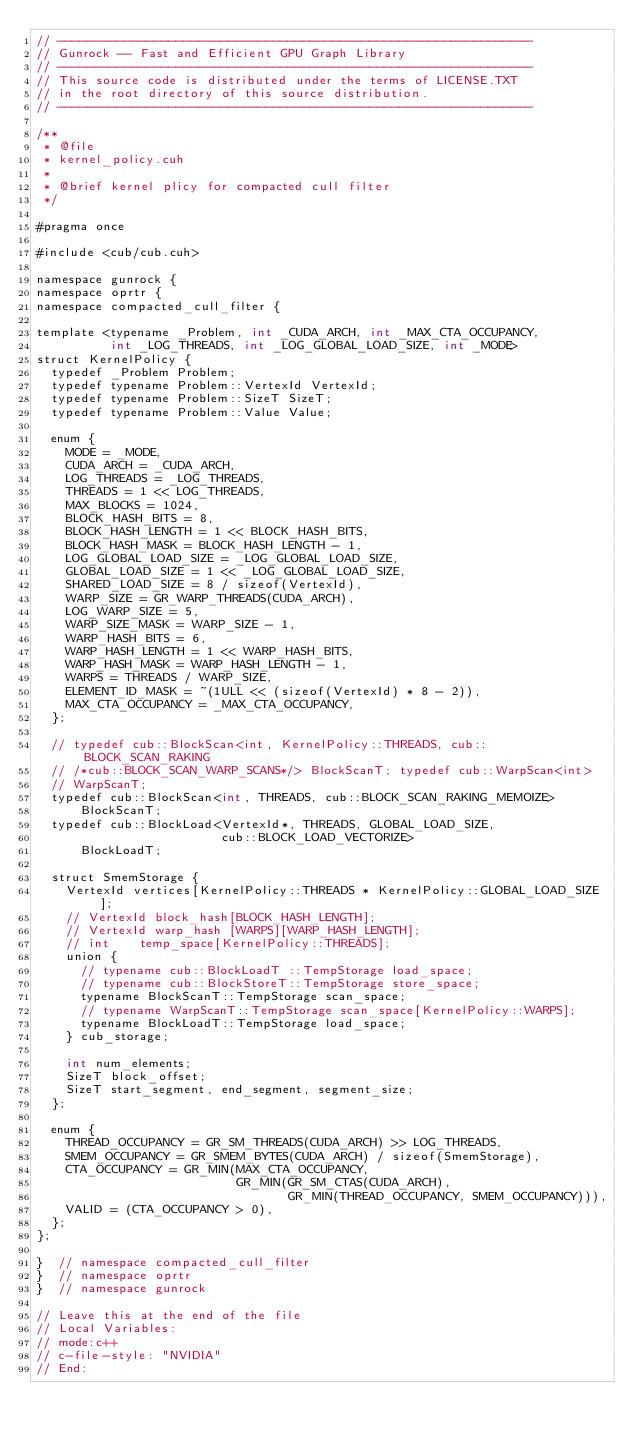<code> <loc_0><loc_0><loc_500><loc_500><_Cuda_>// ----------------------------------------------------------------
// Gunrock -- Fast and Efficient GPU Graph Library
// ----------------------------------------------------------------
// This source code is distributed under the terms of LICENSE.TXT
// in the root directory of this source distribution.
// ----------------------------------------------------------------

/**
 * @file
 * kernel_policy.cuh
 *
 * @brief kernel plicy for compacted cull filter
 */

#pragma once

#include <cub/cub.cuh>

namespace gunrock {
namespace oprtr {
namespace compacted_cull_filter {

template <typename _Problem, int _CUDA_ARCH, int _MAX_CTA_OCCUPANCY,
          int _LOG_THREADS, int _LOG_GLOBAL_LOAD_SIZE, int _MODE>
struct KernelPolicy {
  typedef _Problem Problem;
  typedef typename Problem::VertexId VertexId;
  typedef typename Problem::SizeT SizeT;
  typedef typename Problem::Value Value;

  enum {
    MODE = _MODE,
    CUDA_ARCH = _CUDA_ARCH,
    LOG_THREADS = _LOG_THREADS,
    THREADS = 1 << LOG_THREADS,
    MAX_BLOCKS = 1024,
    BLOCK_HASH_BITS = 8,
    BLOCK_HASH_LENGTH = 1 << BLOCK_HASH_BITS,
    BLOCK_HASH_MASK = BLOCK_HASH_LENGTH - 1,
    LOG_GLOBAL_LOAD_SIZE = _LOG_GLOBAL_LOAD_SIZE,
    GLOBAL_LOAD_SIZE = 1 << _LOG_GLOBAL_LOAD_SIZE,
    SHARED_LOAD_SIZE = 8 / sizeof(VertexId),
    WARP_SIZE = GR_WARP_THREADS(CUDA_ARCH),
    LOG_WARP_SIZE = 5,
    WARP_SIZE_MASK = WARP_SIZE - 1,
    WARP_HASH_BITS = 6,
    WARP_HASH_LENGTH = 1 << WARP_HASH_BITS,
    WARP_HASH_MASK = WARP_HASH_LENGTH - 1,
    WARPS = THREADS / WARP_SIZE,
    ELEMENT_ID_MASK = ~(1ULL << (sizeof(VertexId) * 8 - 2)),
    MAX_CTA_OCCUPANCY = _MAX_CTA_OCCUPANCY,
  };

  // typedef cub::BlockScan<int, KernelPolicy::THREADS, cub::BLOCK_SCAN_RAKING
  // /*cub::BLOCK_SCAN_WARP_SCANS*/> BlockScanT; typedef cub::WarpScan<int>
  // WarpScanT;
  typedef cub::BlockScan<int, THREADS, cub::BLOCK_SCAN_RAKING_MEMOIZE>
      BlockScanT;
  typedef cub::BlockLoad<VertexId*, THREADS, GLOBAL_LOAD_SIZE,
                         cub::BLOCK_LOAD_VECTORIZE>
      BlockLoadT;

  struct SmemStorage {
    VertexId vertices[KernelPolicy::THREADS * KernelPolicy::GLOBAL_LOAD_SIZE];
    // VertexId block_hash[BLOCK_HASH_LENGTH];
    // VertexId warp_hash [WARPS][WARP_HASH_LENGTH];
    // int    temp_space[KernelPolicy::THREADS];
    union {
      // typename cub::BlockLoadT ::TempStorage load_space;
      // typename cub::BlockStoreT::TempStorage store_space;
      typename BlockScanT::TempStorage scan_space;
      // typename WarpScanT::TempStorage scan_space[KernelPolicy::WARPS];
      typename BlockLoadT::TempStorage load_space;
    } cub_storage;

    int num_elements;
    SizeT block_offset;
    SizeT start_segment, end_segment, segment_size;
  };

  enum {
    THREAD_OCCUPANCY = GR_SM_THREADS(CUDA_ARCH) >> LOG_THREADS,
    SMEM_OCCUPANCY = GR_SMEM_BYTES(CUDA_ARCH) / sizeof(SmemStorage),
    CTA_OCCUPANCY = GR_MIN(MAX_CTA_OCCUPANCY,
                           GR_MIN(GR_SM_CTAS(CUDA_ARCH),
                                  GR_MIN(THREAD_OCCUPANCY, SMEM_OCCUPANCY))),
    VALID = (CTA_OCCUPANCY > 0),
  };
};

}  // namespace compacted_cull_filter
}  // namespace oprtr
}  // namespace gunrock

// Leave this at the end of the file
// Local Variables:
// mode:c++
// c-file-style: "NVIDIA"
// End:
</code> 